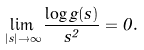<formula> <loc_0><loc_0><loc_500><loc_500>\lim _ { | s | \to \infty } \frac { \log g ( s ) } { s ^ { 2 } } = 0 .</formula> 